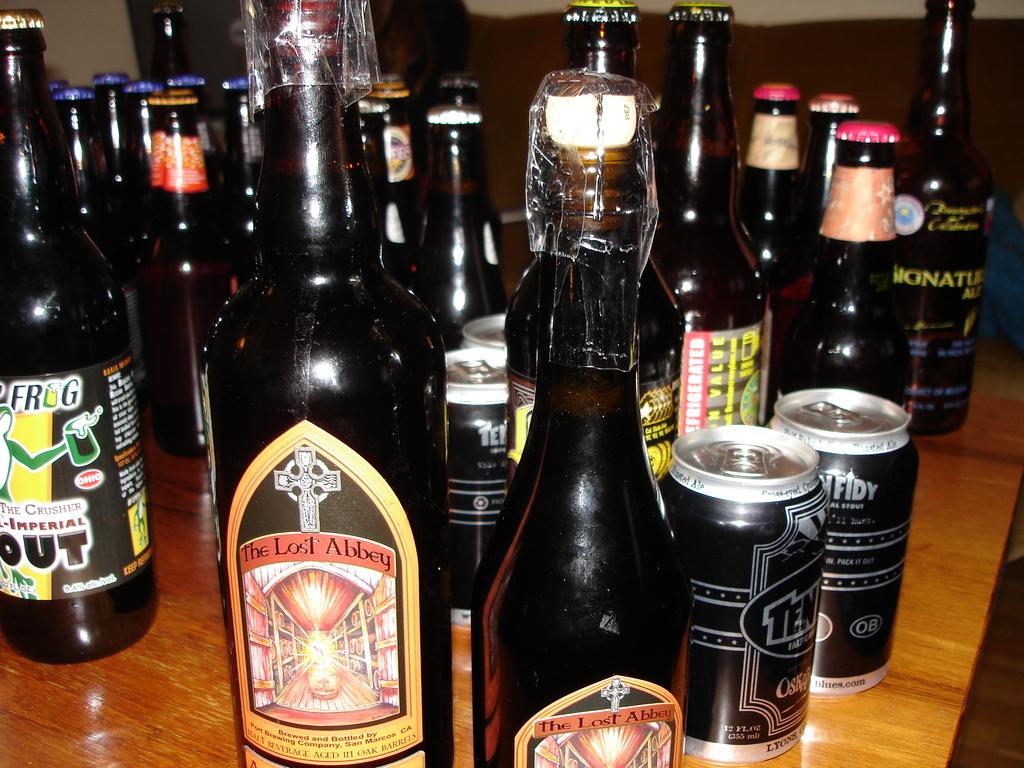What brewery produced the closest beer?
Offer a terse response. The lost abbey. What animal is named on the bottle on the left?
Make the answer very short. Frog. 